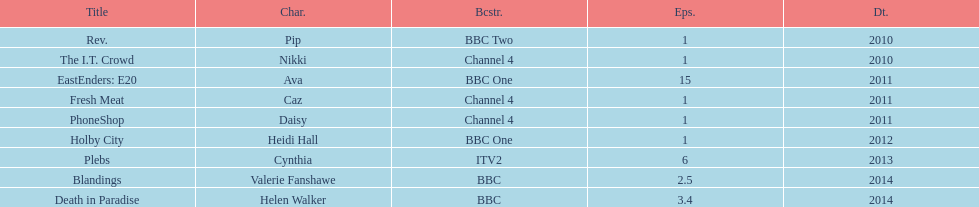How many titles consist of a minimum of 5 episodes? 2. 